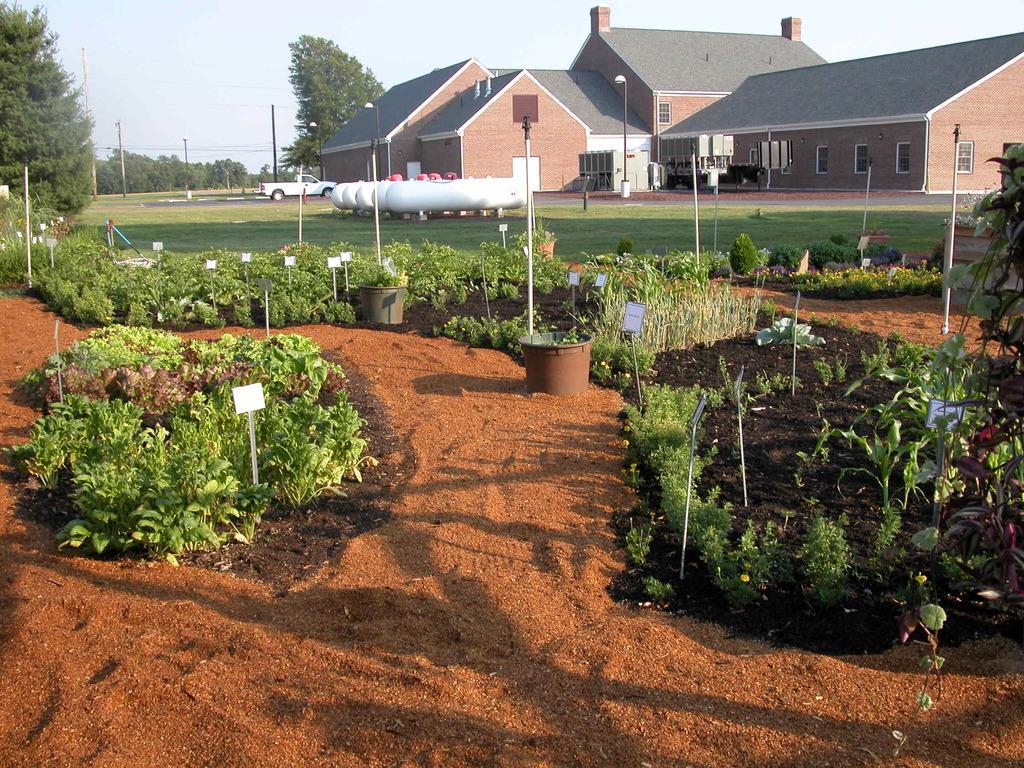Can you describe this image briefly? This image consists of plants. At the bottom, there is soil. In the background, we can see the tanks and a house. On the left, there is a car. In the background, there are trees. At the top, there is sky. 